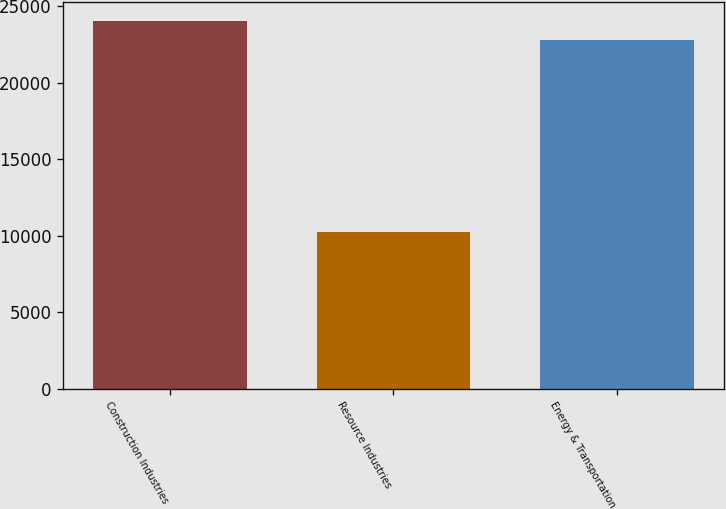Convert chart. <chart><loc_0><loc_0><loc_500><loc_500><bar_chart><fcel>Construction Industries<fcel>Resource Industries<fcel>Energy & Transportation<nl><fcel>24081.7<fcel>10270<fcel>22785<nl></chart> 